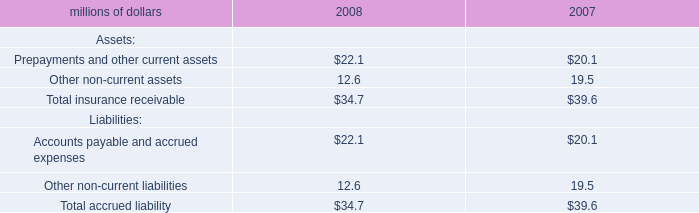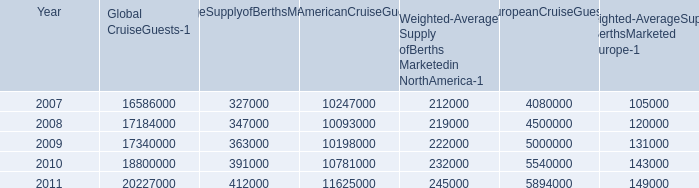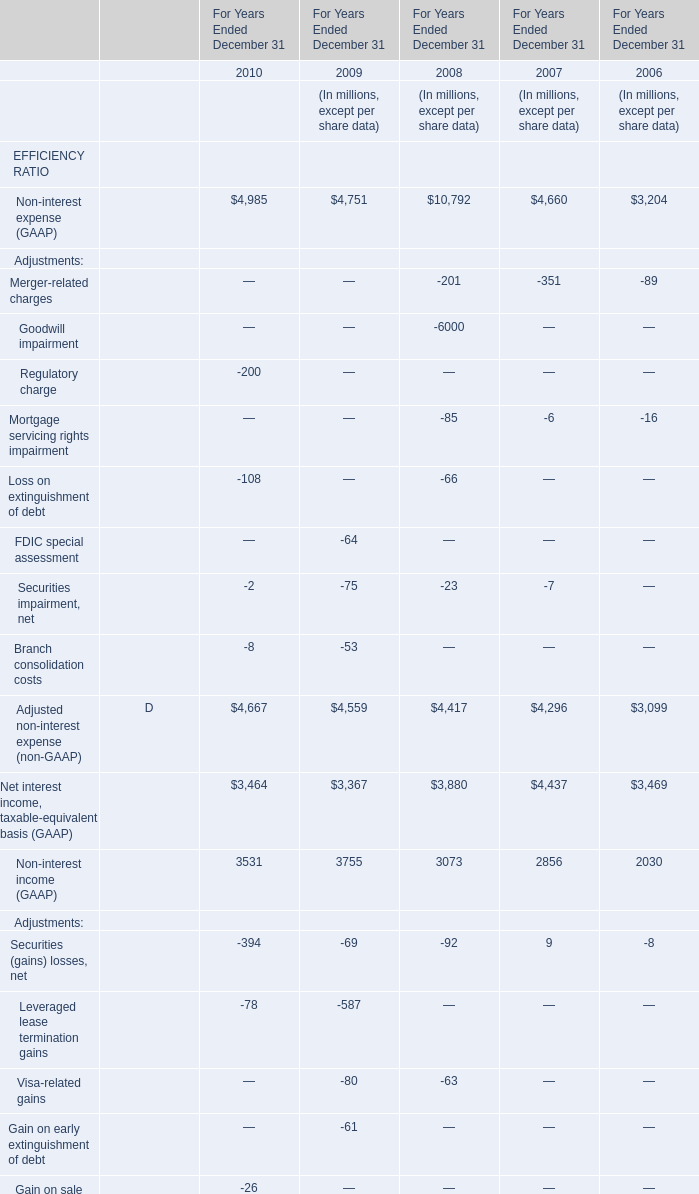what was the percent of the anticipated increased in the berths capacity to service european cruise market between 2012 and 2016 
Computations: (28000 / 155000)
Answer: 0.18065. 